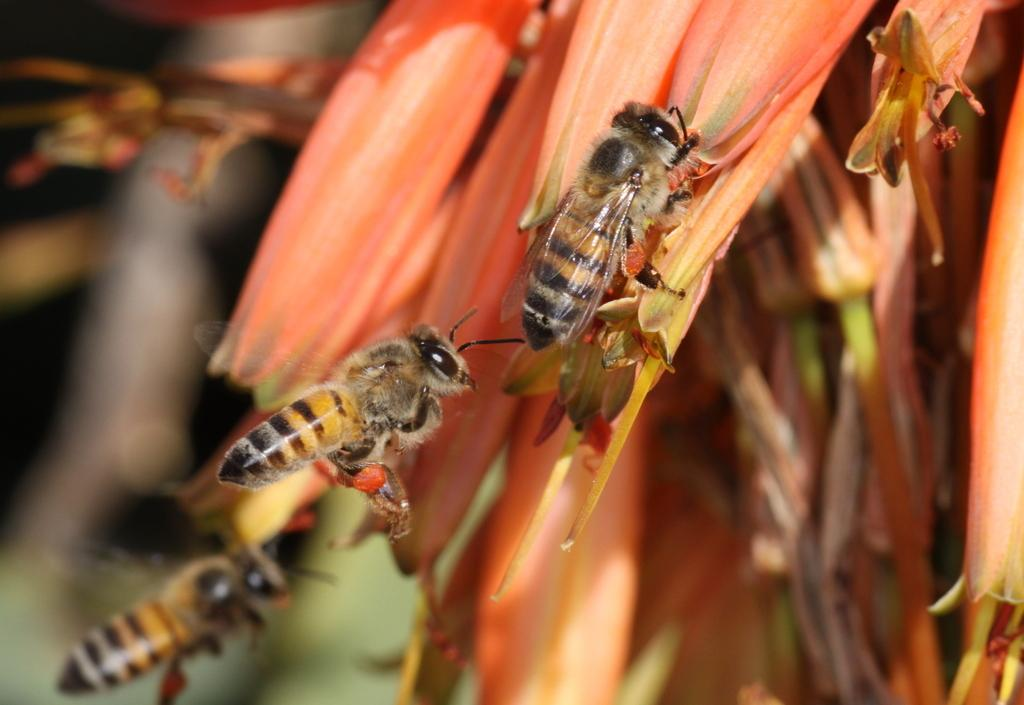What is the main subject of the image? The main subject of the image is a bee on a flower. Are there any other bees visible in the image? Yes, there is another bee in the air and a third bee in the background of the image. What else can be seen in the image besides the bees? There are flowers in the background of the image. How is the background of the image depicted? The background is blurred. What type of wound can be seen on the bee's trousers in the image? There are no trousers present in the image, as bees do not wear clothing. 